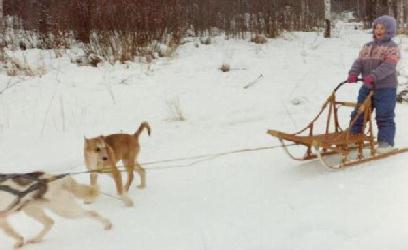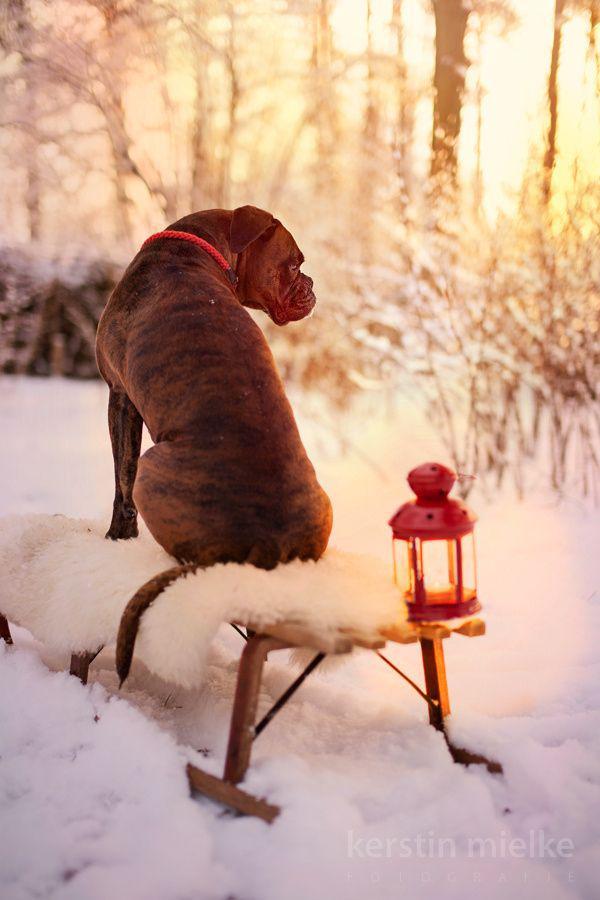The first image is the image on the left, the second image is the image on the right. Given the left and right images, does the statement "In only one of the two images are the dogs awake." hold true? Answer yes or no. No. 